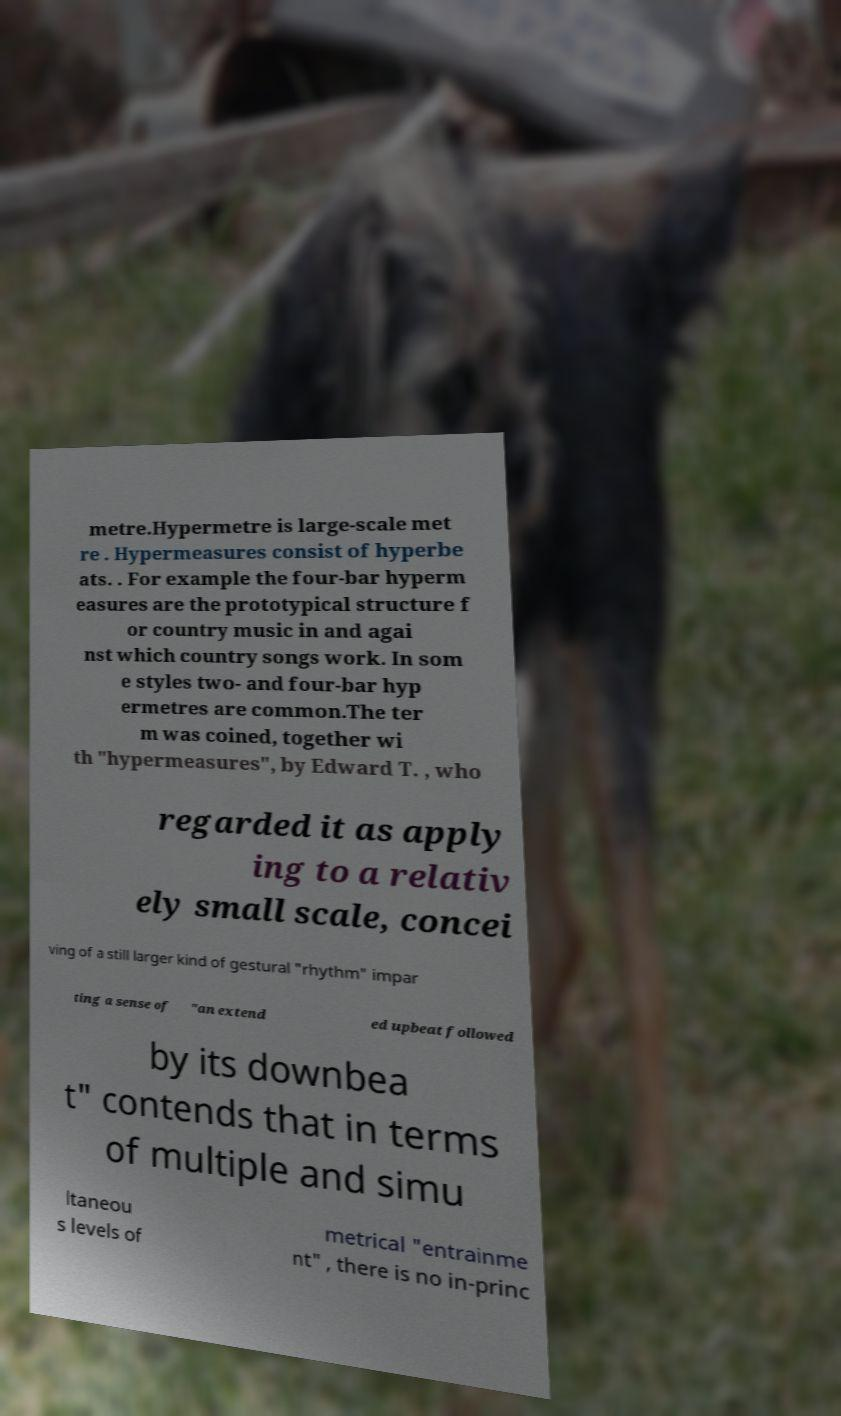Can you read and provide the text displayed in the image?This photo seems to have some interesting text. Can you extract and type it out for me? metre.Hypermetre is large-scale met re . Hypermeasures consist of hyperbe ats. . For example the four-bar hyperm easures are the prototypical structure f or country music in and agai nst which country songs work. In som e styles two- and four-bar hyp ermetres are common.The ter m was coined, together wi th "hypermeasures", by Edward T. , who regarded it as apply ing to a relativ ely small scale, concei ving of a still larger kind of gestural "rhythm" impar ting a sense of "an extend ed upbeat followed by its downbea t" contends that in terms of multiple and simu ltaneou s levels of metrical "entrainme nt" , there is no in-princ 